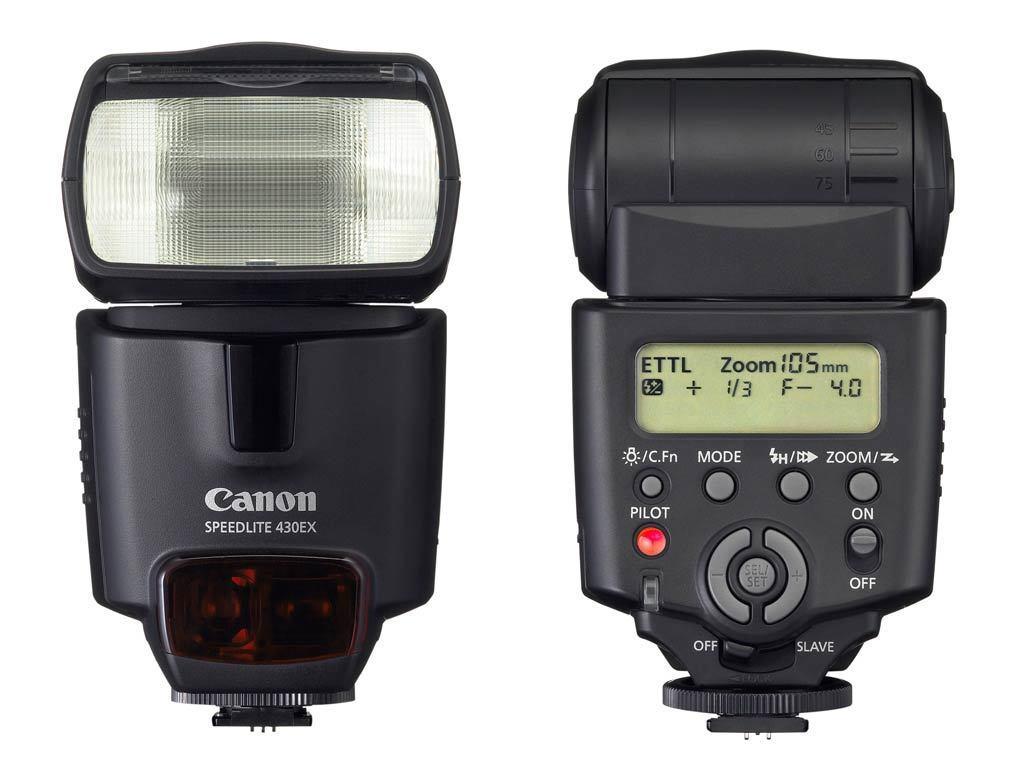Can you describe this image briefly? In the image there are parts of camera. On the left side of the image there is a flash light of a camera and there is something written on it. On the right side of the image there is a part with screen and buttons. 